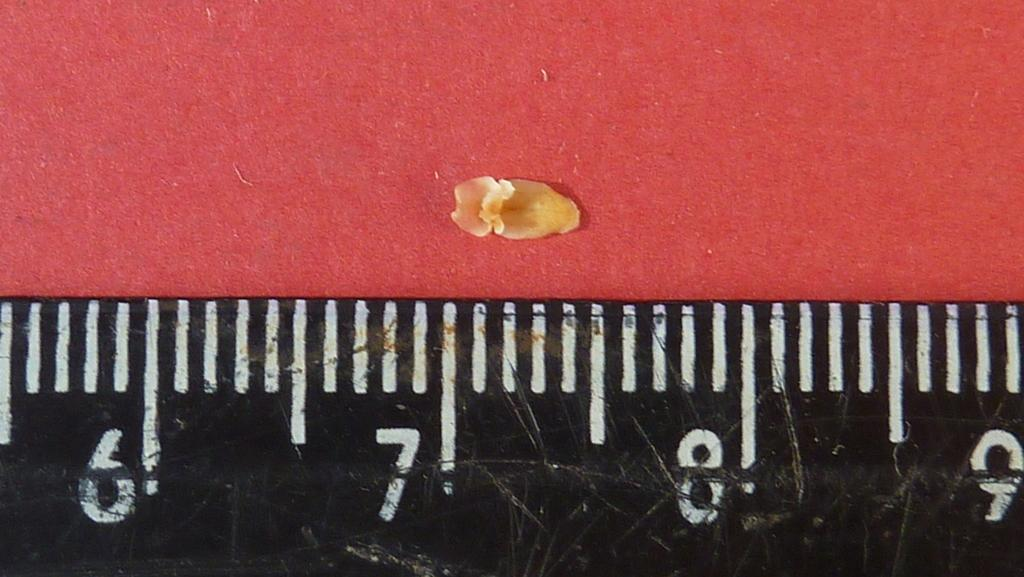<image>
Render a clear and concise summary of the photo. Something small is being measured against  a ruler between the seven and seven and a half inch marks. 